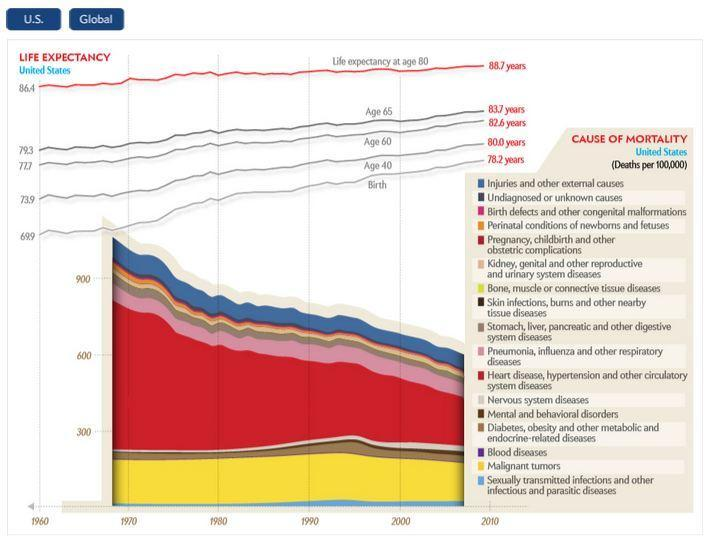Which color represents the cause of highest mortality rate in the US, black, brown or red??
Answer the question with a short phrase. red What is the count of the causes of mortality in US? 17 